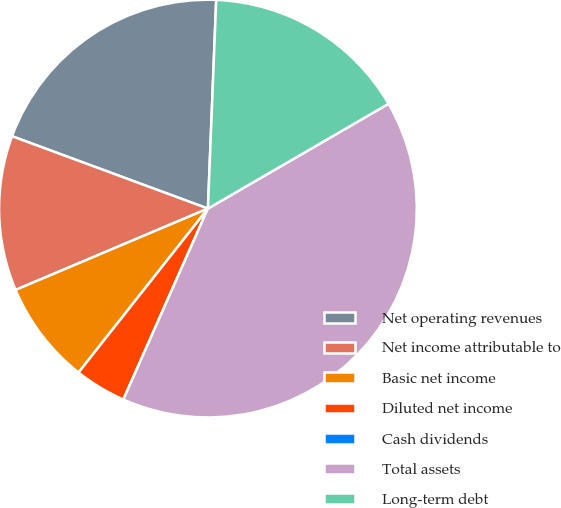Convert chart to OTSL. <chart><loc_0><loc_0><loc_500><loc_500><pie_chart><fcel>Net operating revenues<fcel>Net income attributable to<fcel>Basic net income<fcel>Diluted net income<fcel>Cash dividends<fcel>Total assets<fcel>Long-term debt<nl><fcel>20.0%<fcel>12.0%<fcel>8.0%<fcel>4.0%<fcel>0.0%<fcel>40.0%<fcel>16.0%<nl></chart> 